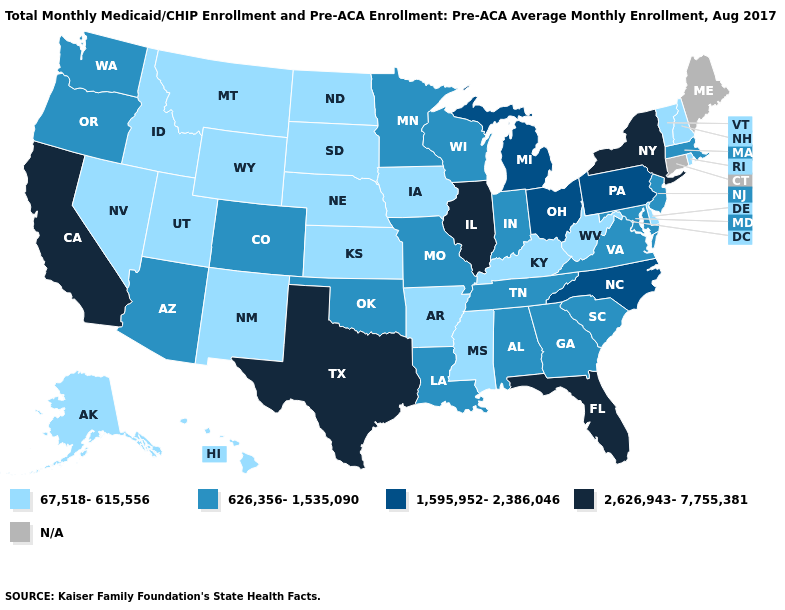What is the value of Illinois?
Short answer required. 2,626,943-7,755,381. What is the highest value in states that border Rhode Island?
Short answer required. 626,356-1,535,090. Name the states that have a value in the range N/A?
Short answer required. Connecticut, Maine. What is the value of Nebraska?
Be succinct. 67,518-615,556. Which states have the highest value in the USA?
Answer briefly. California, Florida, Illinois, New York, Texas. Name the states that have a value in the range 626,356-1,535,090?
Answer briefly. Alabama, Arizona, Colorado, Georgia, Indiana, Louisiana, Maryland, Massachusetts, Minnesota, Missouri, New Jersey, Oklahoma, Oregon, South Carolina, Tennessee, Virginia, Washington, Wisconsin. Is the legend a continuous bar?
Give a very brief answer. No. Which states have the highest value in the USA?
Quick response, please. California, Florida, Illinois, New York, Texas. Is the legend a continuous bar?
Be succinct. No. What is the highest value in the USA?
Write a very short answer. 2,626,943-7,755,381. What is the value of New Mexico?
Concise answer only. 67,518-615,556. What is the lowest value in states that border Maine?
Answer briefly. 67,518-615,556. How many symbols are there in the legend?
Give a very brief answer. 5. Name the states that have a value in the range 1,595,952-2,386,046?
Concise answer only. Michigan, North Carolina, Ohio, Pennsylvania. 